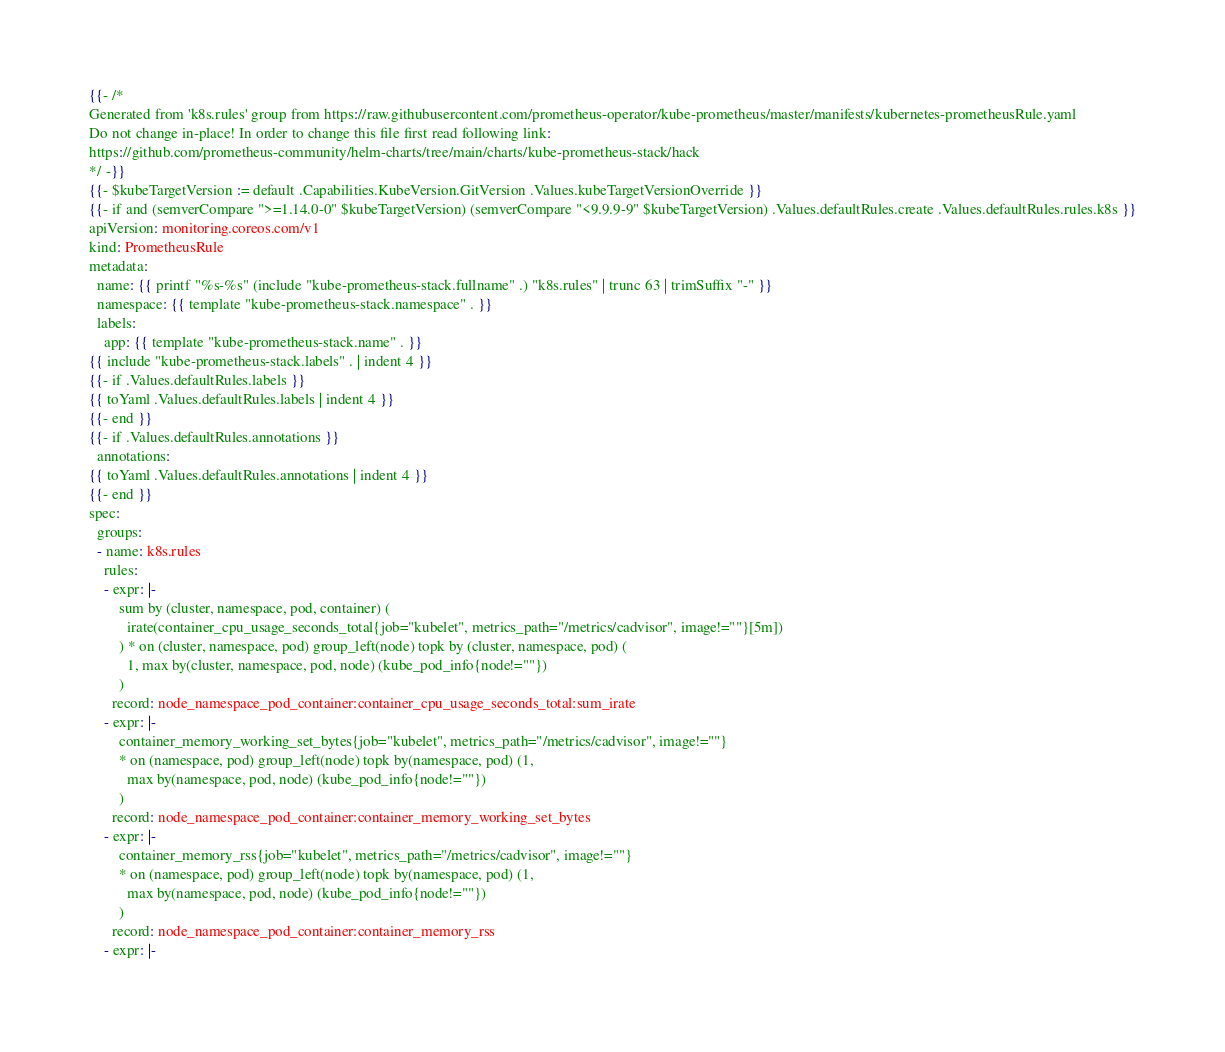Convert code to text. <code><loc_0><loc_0><loc_500><loc_500><_YAML_>{{- /*
Generated from 'k8s.rules' group from https://raw.githubusercontent.com/prometheus-operator/kube-prometheus/master/manifests/kubernetes-prometheusRule.yaml
Do not change in-place! In order to change this file first read following link:
https://github.com/prometheus-community/helm-charts/tree/main/charts/kube-prometheus-stack/hack
*/ -}}
{{- $kubeTargetVersion := default .Capabilities.KubeVersion.GitVersion .Values.kubeTargetVersionOverride }}
{{- if and (semverCompare ">=1.14.0-0" $kubeTargetVersion) (semverCompare "<9.9.9-9" $kubeTargetVersion) .Values.defaultRules.create .Values.defaultRules.rules.k8s }}
apiVersion: monitoring.coreos.com/v1
kind: PrometheusRule
metadata:
  name: {{ printf "%s-%s" (include "kube-prometheus-stack.fullname" .) "k8s.rules" | trunc 63 | trimSuffix "-" }}
  namespace: {{ template "kube-prometheus-stack.namespace" . }}
  labels:
    app: {{ template "kube-prometheus-stack.name" . }}
{{ include "kube-prometheus-stack.labels" . | indent 4 }}
{{- if .Values.defaultRules.labels }}
{{ toYaml .Values.defaultRules.labels | indent 4 }}
{{- end }}
{{- if .Values.defaultRules.annotations }}
  annotations:
{{ toYaml .Values.defaultRules.annotations | indent 4 }}
{{- end }}
spec:
  groups:
  - name: k8s.rules
    rules:
    - expr: |-
        sum by (cluster, namespace, pod, container) (
          irate(container_cpu_usage_seconds_total{job="kubelet", metrics_path="/metrics/cadvisor", image!=""}[5m])
        ) * on (cluster, namespace, pod) group_left(node) topk by (cluster, namespace, pod) (
          1, max by(cluster, namespace, pod, node) (kube_pod_info{node!=""})
        )
      record: node_namespace_pod_container:container_cpu_usage_seconds_total:sum_irate
    - expr: |-
        container_memory_working_set_bytes{job="kubelet", metrics_path="/metrics/cadvisor", image!=""}
        * on (namespace, pod) group_left(node) topk by(namespace, pod) (1,
          max by(namespace, pod, node) (kube_pod_info{node!=""})
        )
      record: node_namespace_pod_container:container_memory_working_set_bytes
    - expr: |-
        container_memory_rss{job="kubelet", metrics_path="/metrics/cadvisor", image!=""}
        * on (namespace, pod) group_left(node) topk by(namespace, pod) (1,
          max by(namespace, pod, node) (kube_pod_info{node!=""})
        )
      record: node_namespace_pod_container:container_memory_rss
    - expr: |-</code> 